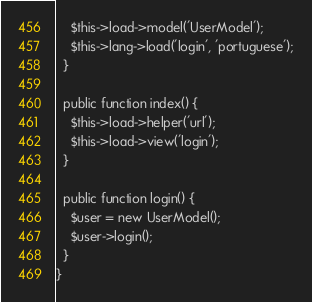Convert code to text. <code><loc_0><loc_0><loc_500><loc_500><_PHP_>    $this->load->model('UserModel');
    $this->lang->load('login', 'portuguese');
  }

  public function index() {
    $this->load->helper('url');
    $this->load->view('login');
  }

  public function login() {
    $user = new UserModel();
    $user->login();
  }
}</code> 